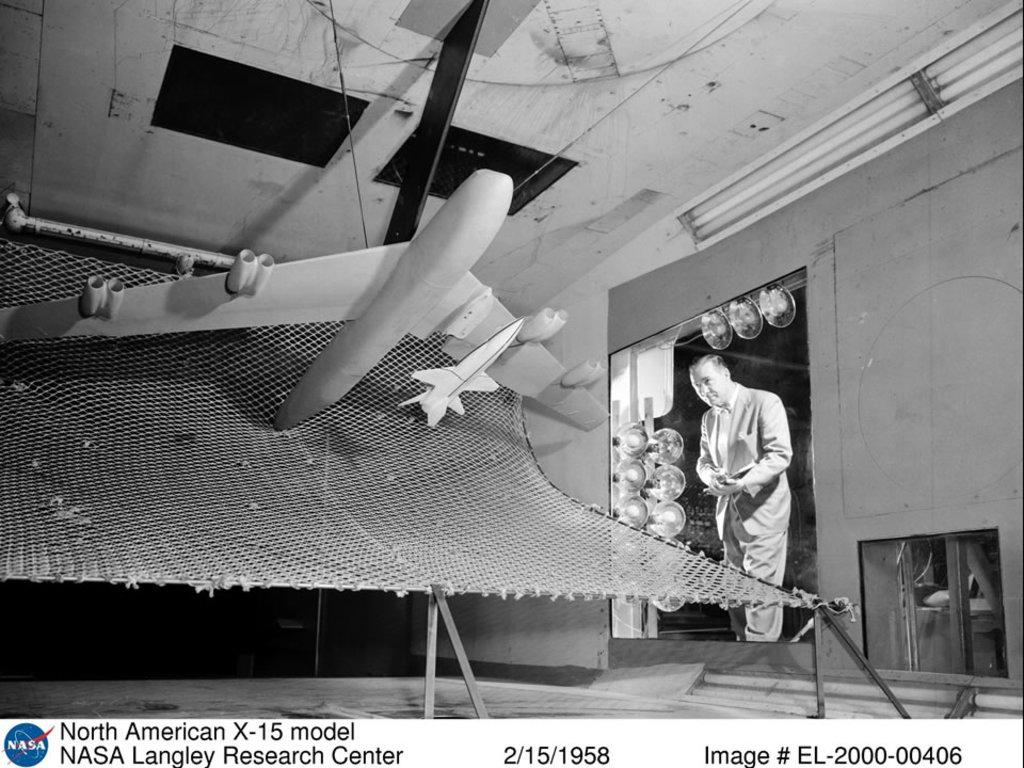<image>
Share a concise interpretation of the image provided. A man is inspecting a model of a North American X-15 jet. 